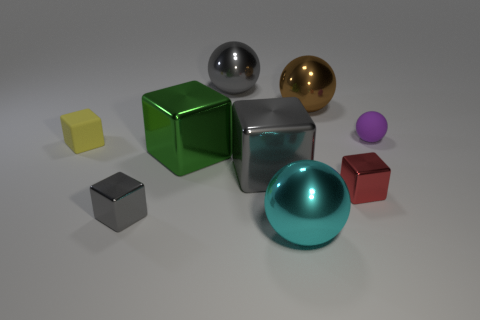Subtract all yellow balls. How many gray cubes are left? 2 Subtract all red cubes. How many cubes are left? 4 Subtract all big metallic spheres. How many spheres are left? 1 Subtract 1 blocks. How many blocks are left? 4 Add 1 blue matte cylinders. How many objects exist? 10 Subtract all blue spheres. Subtract all yellow blocks. How many spheres are left? 4 Subtract all blocks. How many objects are left? 4 Add 8 cyan spheres. How many cyan spheres exist? 9 Subtract 0 red spheres. How many objects are left? 9 Subtract all metallic spheres. Subtract all large green shiny cubes. How many objects are left? 5 